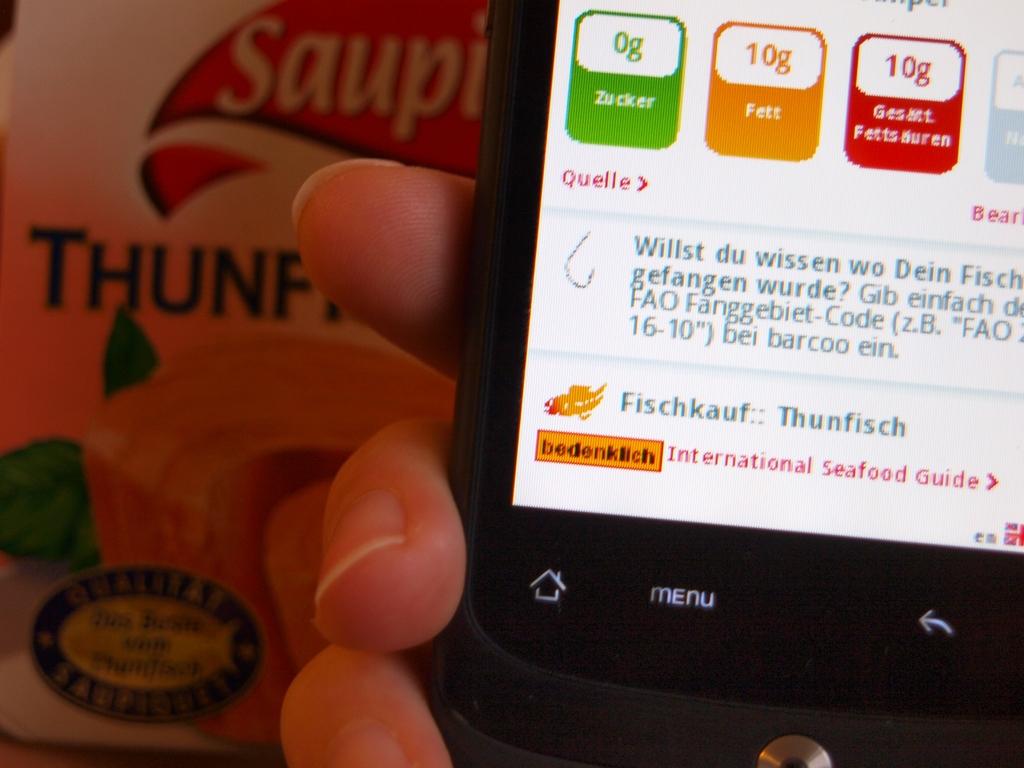How many grams of fett are listed?
Keep it short and to the point. 10g. 